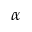<formula> <loc_0><loc_0><loc_500><loc_500>\alpha</formula> 